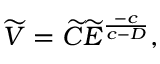<formula> <loc_0><loc_0><loc_500><loc_500>\widetilde { V } = \widetilde { C } \widetilde { E } ^ { \frac { - c } { c - D } } ,</formula> 